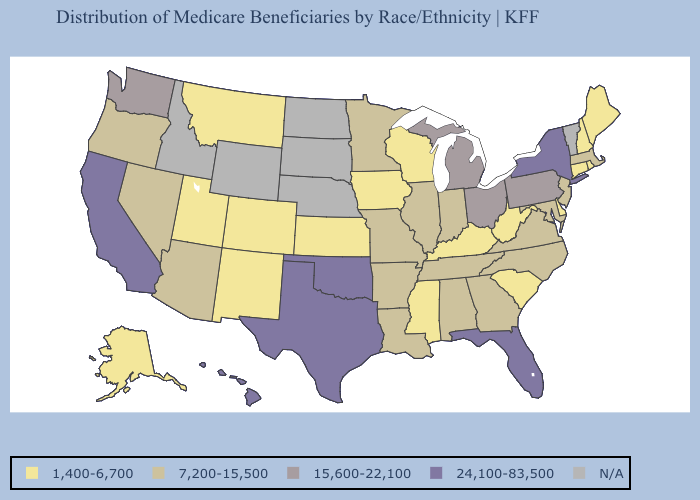Name the states that have a value in the range N/A?
Short answer required. Idaho, Nebraska, North Dakota, South Dakota, Vermont, Wyoming. Among the states that border Michigan , does Wisconsin have the highest value?
Be succinct. No. What is the value of Arizona?
Be succinct. 7,200-15,500. Does Connecticut have the lowest value in the Northeast?
Concise answer only. Yes. What is the highest value in states that border Connecticut?
Answer briefly. 24,100-83,500. Name the states that have a value in the range 7,200-15,500?
Quick response, please. Alabama, Arizona, Arkansas, Georgia, Illinois, Indiana, Louisiana, Maryland, Massachusetts, Minnesota, Missouri, Nevada, New Jersey, North Carolina, Oregon, Tennessee, Virginia. Does Hawaii have the highest value in the West?
Concise answer only. Yes. What is the lowest value in the South?
Be succinct. 1,400-6,700. Which states hav the highest value in the South?
Give a very brief answer. Florida, Oklahoma, Texas. What is the lowest value in the USA?
Keep it brief. 1,400-6,700. What is the value of California?
Short answer required. 24,100-83,500. Among the states that border Maine , which have the highest value?
Answer briefly. New Hampshire. Does the map have missing data?
Concise answer only. Yes. What is the value of Colorado?
Keep it brief. 1,400-6,700. How many symbols are there in the legend?
Give a very brief answer. 5. 